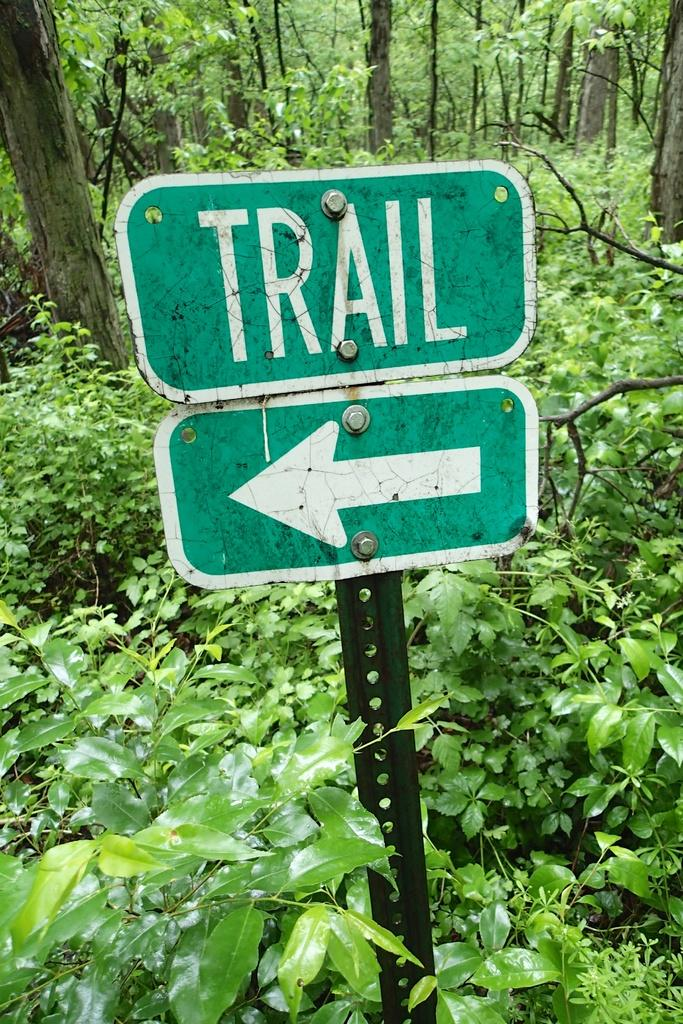<image>
Describe the image concisely. A sign in the forest that reads TRAIL with and arrow pointing to the left. 